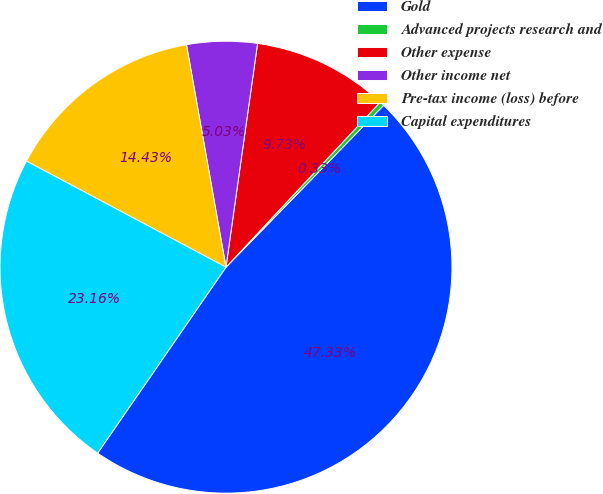Convert chart. <chart><loc_0><loc_0><loc_500><loc_500><pie_chart><fcel>Gold<fcel>Advanced projects research and<fcel>Other expense<fcel>Other income net<fcel>Pre-tax income (loss) before<fcel>Capital expenditures<nl><fcel>47.33%<fcel>0.33%<fcel>9.73%<fcel>5.03%<fcel>14.43%<fcel>23.16%<nl></chart> 